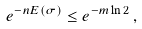<formula> <loc_0><loc_0><loc_500><loc_500>e ^ { - n E ( \sigma ) } \leq e ^ { - m \ln 2 } \, ,</formula> 